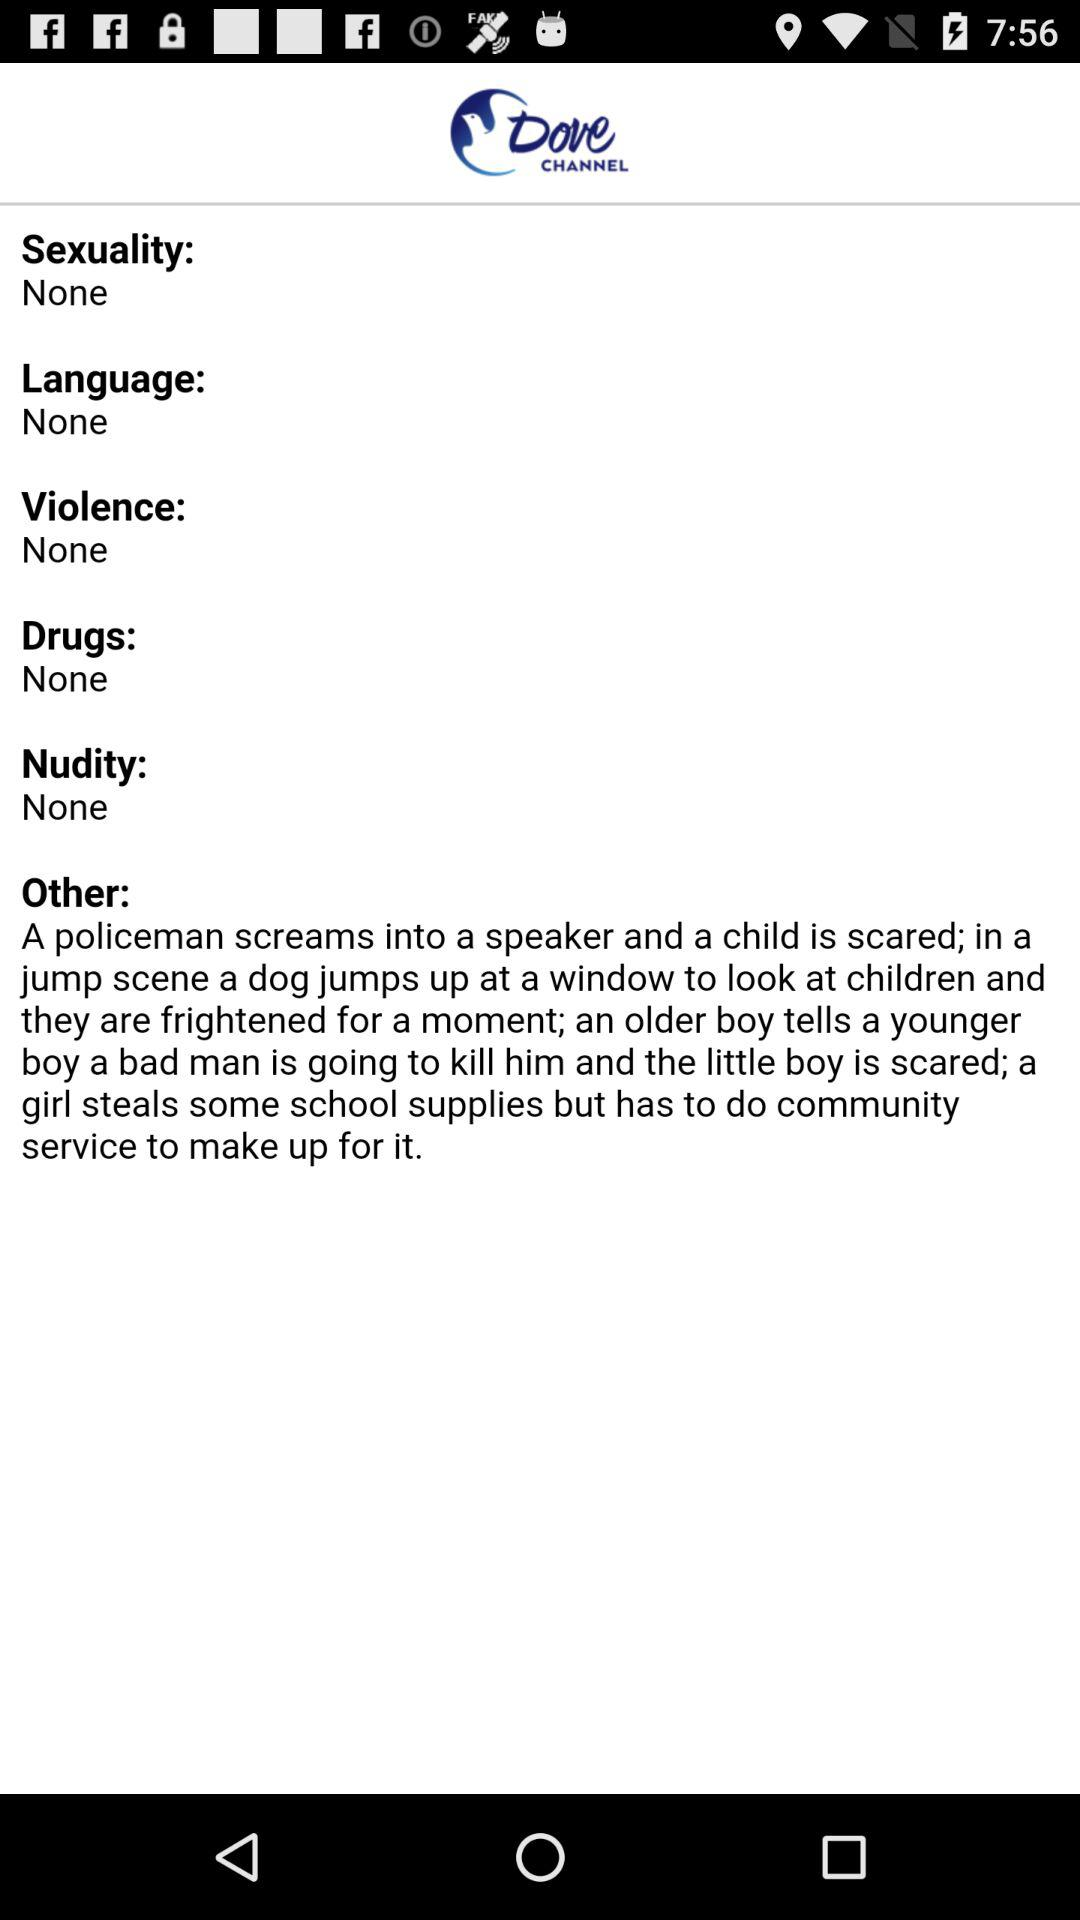What option is selected in nudity? The selected option is "None". 